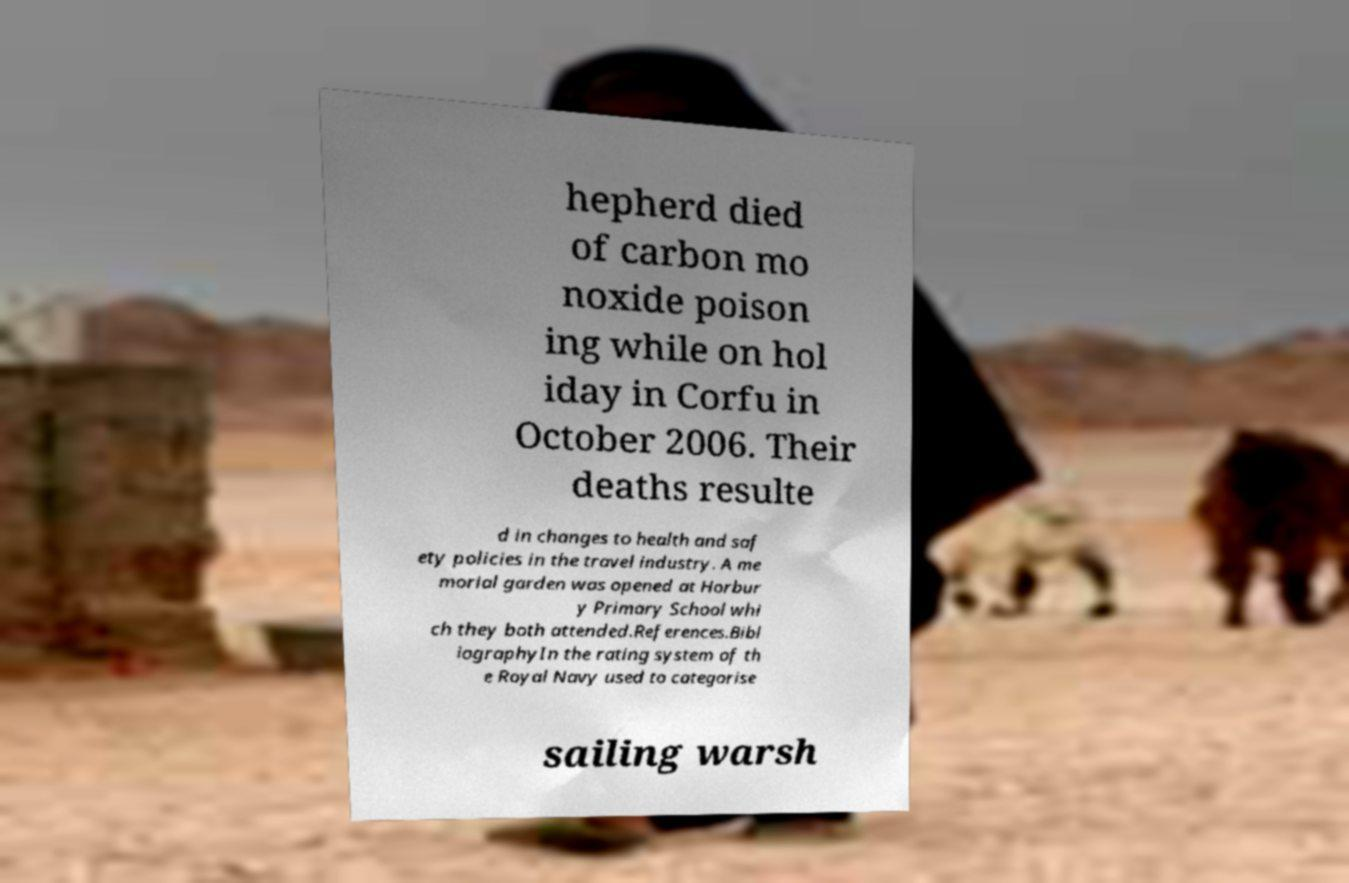Please read and relay the text visible in this image. What does it say? hepherd died of carbon mo noxide poison ing while on hol iday in Corfu in October 2006. Their deaths resulte d in changes to health and saf ety policies in the travel industry. A me morial garden was opened at Horbur y Primary School whi ch they both attended.References.Bibl iographyIn the rating system of th e Royal Navy used to categorise sailing warsh 